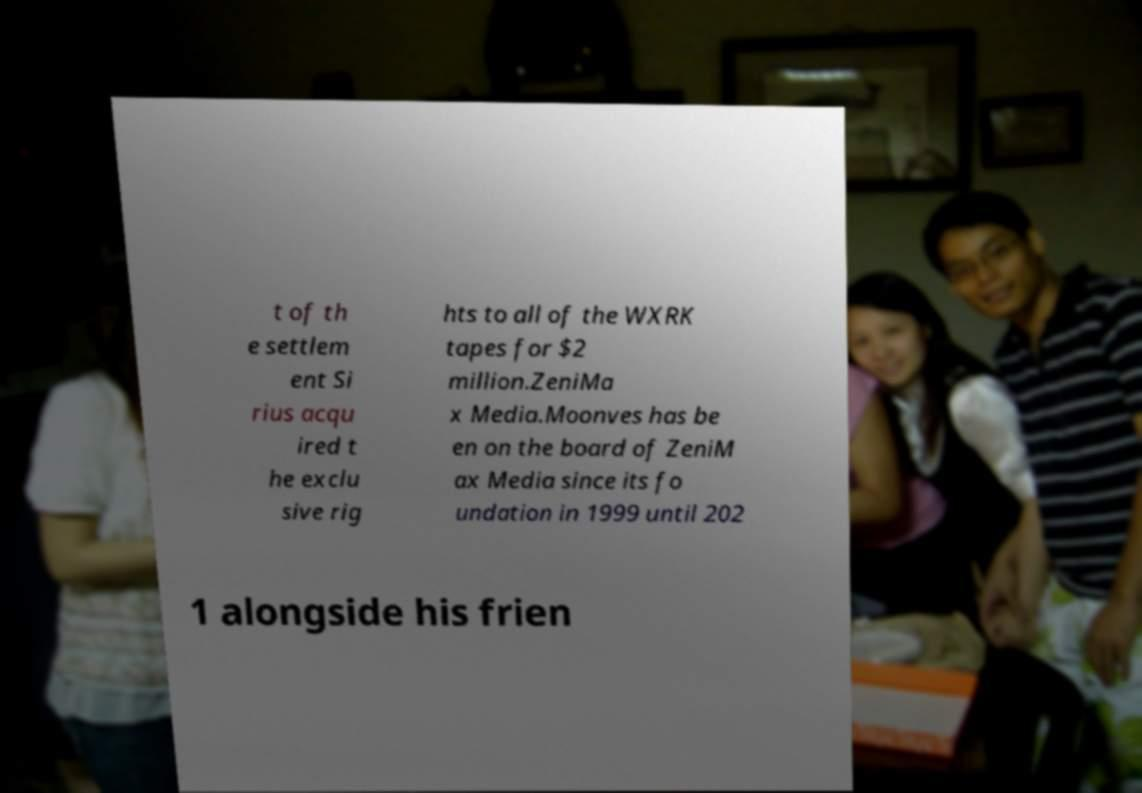For documentation purposes, I need the text within this image transcribed. Could you provide that? t of th e settlem ent Si rius acqu ired t he exclu sive rig hts to all of the WXRK tapes for $2 million.ZeniMa x Media.Moonves has be en on the board of ZeniM ax Media since its fo undation in 1999 until 202 1 alongside his frien 